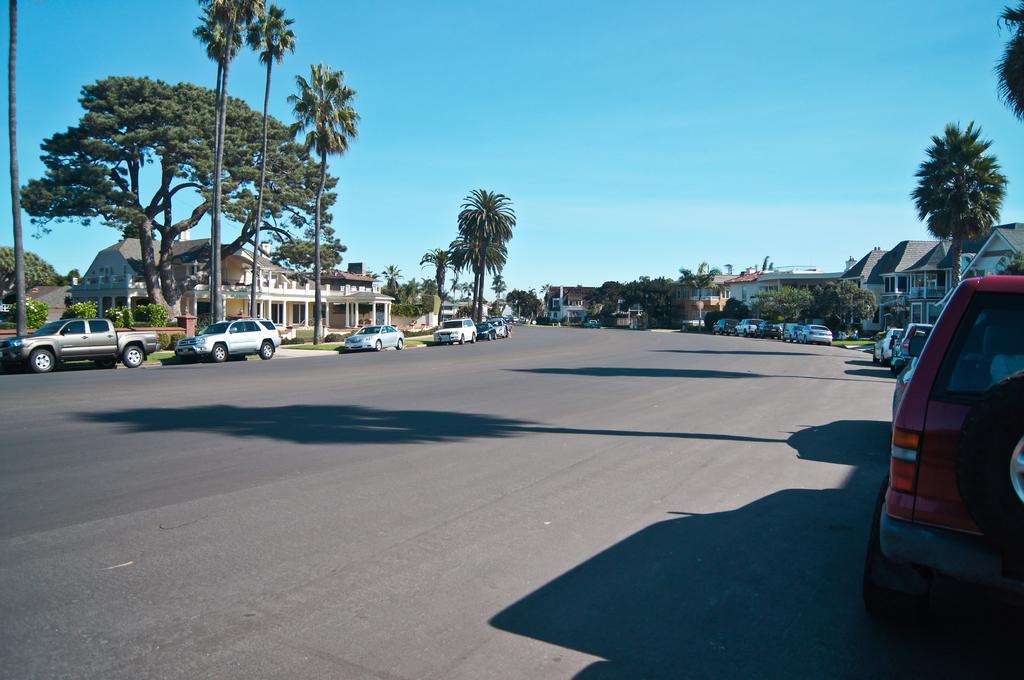What type of natural elements can be seen in the image? There are trees in the image. What type of man-made structures are visible in the image? There are buildings in the image. What type of transportation is parked on the road in the image? There are vehicles parked on the road in the image. What is visible at the top of the image? The sky is visible at the top of the image. What is the texture of the class in the image? There is no class present in the image, and therefore no texture can be determined. How do the acoustics of the image affect the sound of the vehicles? The image does not provide any information about the acoustics, so it is impossible to determine how they might affect the sound of the vehicles. 